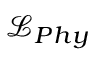<formula> <loc_0><loc_0><loc_500><loc_500>\mathcal { L } _ { P h y }</formula> 